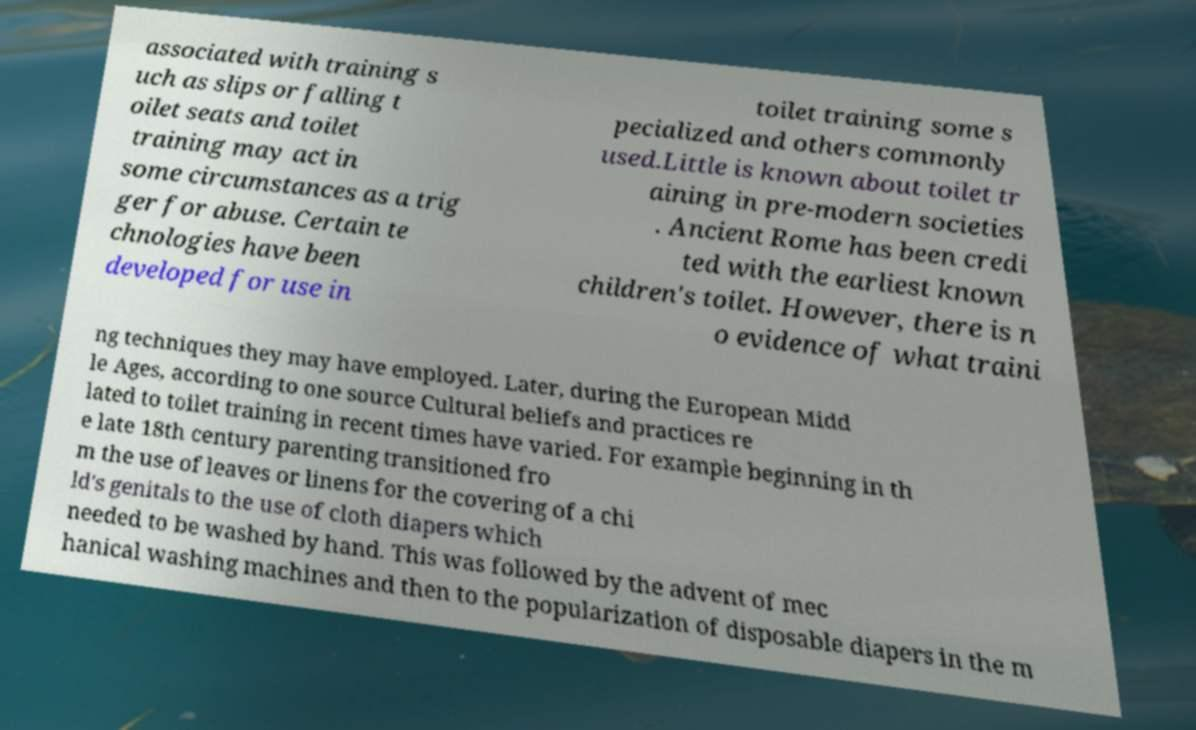Could you assist in decoding the text presented in this image and type it out clearly? associated with training s uch as slips or falling t oilet seats and toilet training may act in some circumstances as a trig ger for abuse. Certain te chnologies have been developed for use in toilet training some s pecialized and others commonly used.Little is known about toilet tr aining in pre-modern societies . Ancient Rome has been credi ted with the earliest known children's toilet. However, there is n o evidence of what traini ng techniques they may have employed. Later, during the European Midd le Ages, according to one source Cultural beliefs and practices re lated to toilet training in recent times have varied. For example beginning in th e late 18th century parenting transitioned fro m the use of leaves or linens for the covering of a chi ld's genitals to the use of cloth diapers which needed to be washed by hand. This was followed by the advent of mec hanical washing machines and then to the popularization of disposable diapers in the m 